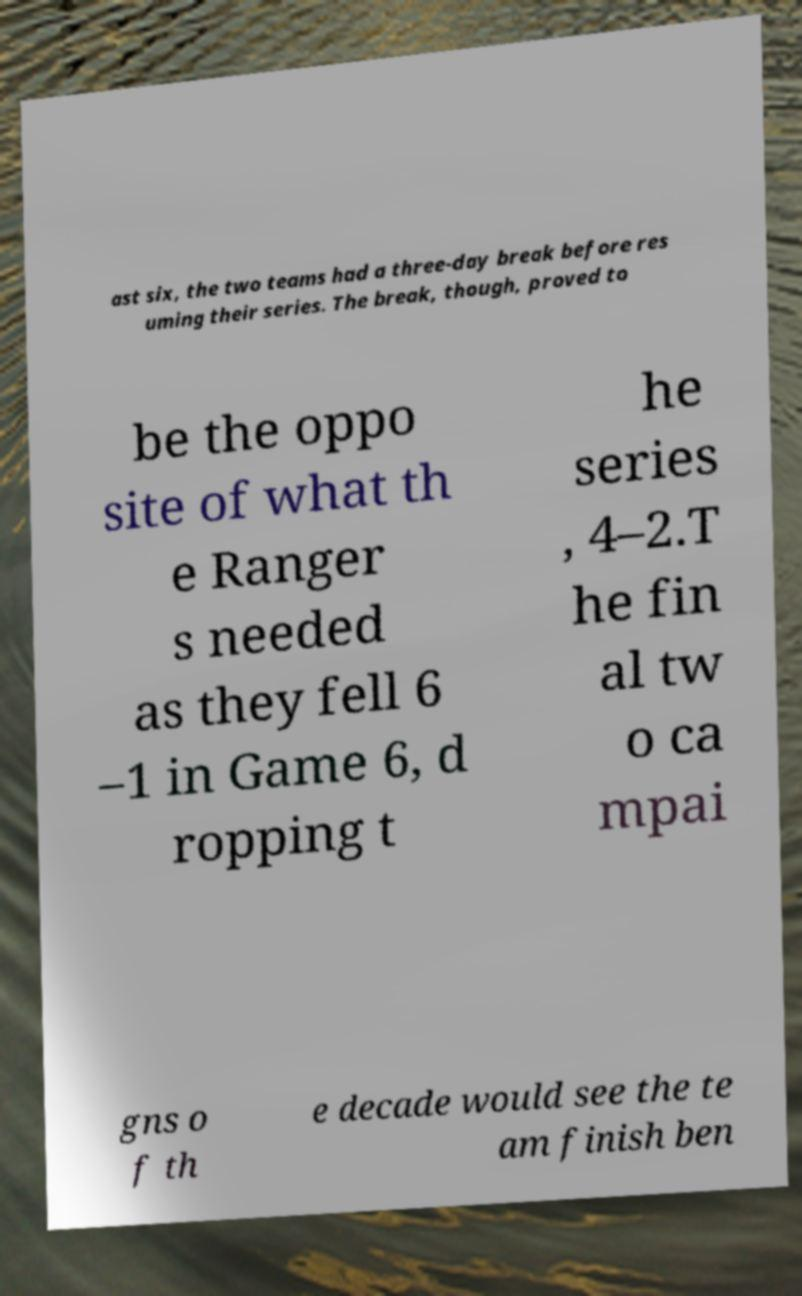For documentation purposes, I need the text within this image transcribed. Could you provide that? ast six, the two teams had a three-day break before res uming their series. The break, though, proved to be the oppo site of what th e Ranger s needed as they fell 6 –1 in Game 6, d ropping t he series , 4–2.T he fin al tw o ca mpai gns o f th e decade would see the te am finish ben 